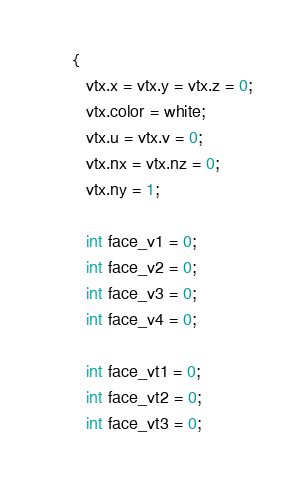<code> <loc_0><loc_0><loc_500><loc_500><_C++_>      {
         vtx.x = vtx.y = vtx.z = 0;
         vtx.color = white;
         vtx.u = vtx.v = 0;
         vtx.nx = vtx.nz = 0;
         vtx.ny = 1;

         int face_v1 = 0;
         int face_v2 = 0;
         int face_v3 = 0;
         int face_v4 = 0;

         int face_vt1 = 0;
         int face_vt2 = 0;
         int face_vt3 = 0;</code> 